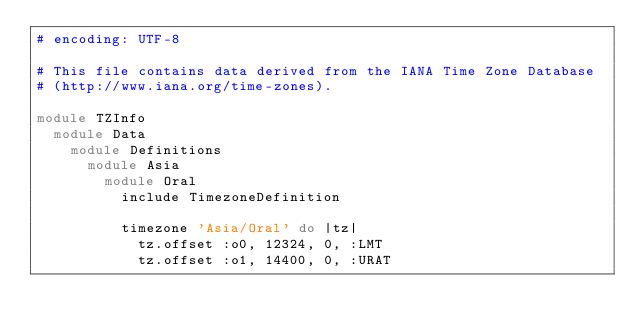Convert code to text. <code><loc_0><loc_0><loc_500><loc_500><_Ruby_># encoding: UTF-8

# This file contains data derived from the IANA Time Zone Database
# (http://www.iana.org/time-zones).

module TZInfo
  module Data
    module Definitions
      module Asia
        module Oral
          include TimezoneDefinition
          
          timezone 'Asia/Oral' do |tz|
            tz.offset :o0, 12324, 0, :LMT
            tz.offset :o1, 14400, 0, :URAT</code> 